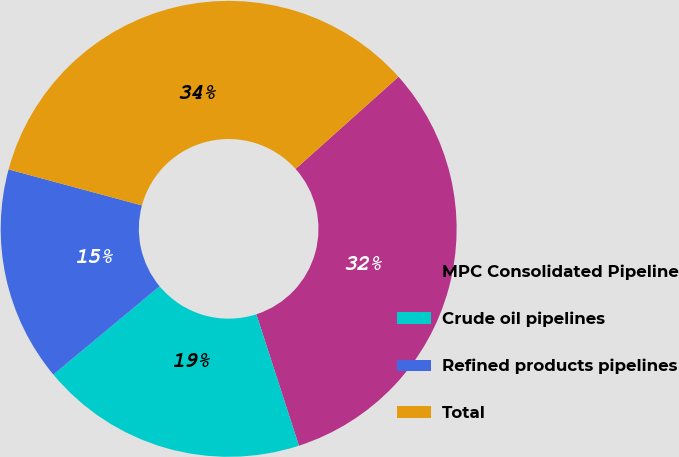Convert chart to OTSL. <chart><loc_0><loc_0><loc_500><loc_500><pie_chart><fcel>MPC Consolidated Pipeline<fcel>Crude oil pipelines<fcel>Refined products pipelines<fcel>Total<nl><fcel>31.63%<fcel>18.95%<fcel>15.23%<fcel>34.18%<nl></chart> 